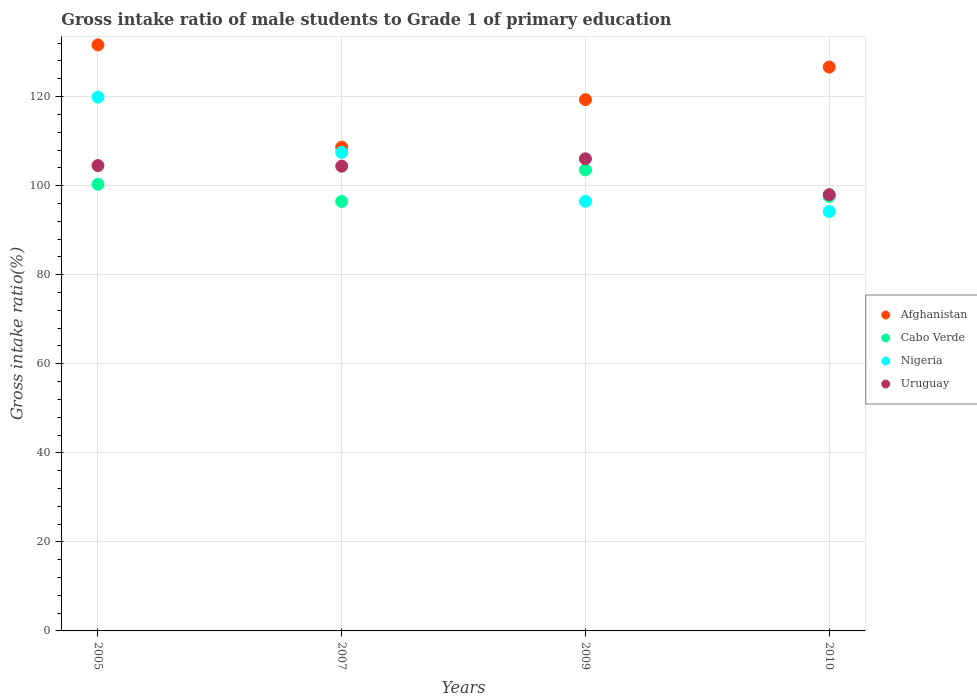What is the gross intake ratio in Nigeria in 2009?
Give a very brief answer. 96.48. Across all years, what is the maximum gross intake ratio in Uruguay?
Your response must be concise. 106.03. Across all years, what is the minimum gross intake ratio in Cabo Verde?
Provide a succinct answer. 96.45. In which year was the gross intake ratio in Cabo Verde maximum?
Provide a succinct answer. 2009. In which year was the gross intake ratio in Cabo Verde minimum?
Your answer should be compact. 2007. What is the total gross intake ratio in Uruguay in the graph?
Offer a very short reply. 412.89. What is the difference between the gross intake ratio in Cabo Verde in 2007 and that in 2009?
Your response must be concise. -7.09. What is the difference between the gross intake ratio in Afghanistan in 2005 and the gross intake ratio in Cabo Verde in 2009?
Provide a succinct answer. 28.07. What is the average gross intake ratio in Afghanistan per year?
Your answer should be compact. 121.55. In the year 2009, what is the difference between the gross intake ratio in Uruguay and gross intake ratio in Afghanistan?
Ensure brevity in your answer.  -13.29. What is the ratio of the gross intake ratio in Nigeria in 2007 to that in 2010?
Provide a succinct answer. 1.14. Is the gross intake ratio in Nigeria in 2005 less than that in 2010?
Your response must be concise. No. Is the difference between the gross intake ratio in Uruguay in 2005 and 2010 greater than the difference between the gross intake ratio in Afghanistan in 2005 and 2010?
Your answer should be compact. Yes. What is the difference between the highest and the second highest gross intake ratio in Cabo Verde?
Provide a succinct answer. 3.24. What is the difference between the highest and the lowest gross intake ratio in Nigeria?
Provide a succinct answer. 25.7. Is the sum of the gross intake ratio in Cabo Verde in 2005 and 2007 greater than the maximum gross intake ratio in Afghanistan across all years?
Provide a short and direct response. Yes. Is it the case that in every year, the sum of the gross intake ratio in Afghanistan and gross intake ratio in Uruguay  is greater than the sum of gross intake ratio in Nigeria and gross intake ratio in Cabo Verde?
Give a very brief answer. No. Is it the case that in every year, the sum of the gross intake ratio in Nigeria and gross intake ratio in Afghanistan  is greater than the gross intake ratio in Cabo Verde?
Offer a terse response. Yes. Does the gross intake ratio in Cabo Verde monotonically increase over the years?
Your answer should be very brief. No. Is the gross intake ratio in Cabo Verde strictly greater than the gross intake ratio in Nigeria over the years?
Ensure brevity in your answer.  No. How many dotlines are there?
Make the answer very short. 4. How many years are there in the graph?
Your answer should be very brief. 4. What is the difference between two consecutive major ticks on the Y-axis?
Your response must be concise. 20. Are the values on the major ticks of Y-axis written in scientific E-notation?
Give a very brief answer. No. Does the graph contain any zero values?
Provide a short and direct response. No. Does the graph contain grids?
Your response must be concise. Yes. Where does the legend appear in the graph?
Offer a very short reply. Center right. How are the legend labels stacked?
Your answer should be compact. Vertical. What is the title of the graph?
Offer a very short reply. Gross intake ratio of male students to Grade 1 of primary education. Does "Dominican Republic" appear as one of the legend labels in the graph?
Keep it short and to the point. No. What is the label or title of the X-axis?
Make the answer very short. Years. What is the label or title of the Y-axis?
Your response must be concise. Gross intake ratio(%). What is the Gross intake ratio(%) in Afghanistan in 2005?
Make the answer very short. 131.61. What is the Gross intake ratio(%) in Cabo Verde in 2005?
Give a very brief answer. 100.3. What is the Gross intake ratio(%) in Nigeria in 2005?
Your answer should be compact. 119.88. What is the Gross intake ratio(%) of Uruguay in 2005?
Offer a very short reply. 104.5. What is the Gross intake ratio(%) in Afghanistan in 2007?
Provide a short and direct response. 108.65. What is the Gross intake ratio(%) in Cabo Verde in 2007?
Offer a terse response. 96.45. What is the Gross intake ratio(%) in Nigeria in 2007?
Provide a short and direct response. 107.47. What is the Gross intake ratio(%) in Uruguay in 2007?
Give a very brief answer. 104.38. What is the Gross intake ratio(%) of Afghanistan in 2009?
Ensure brevity in your answer.  119.31. What is the Gross intake ratio(%) in Cabo Verde in 2009?
Ensure brevity in your answer.  103.54. What is the Gross intake ratio(%) of Nigeria in 2009?
Provide a succinct answer. 96.48. What is the Gross intake ratio(%) of Uruguay in 2009?
Your response must be concise. 106.03. What is the Gross intake ratio(%) in Afghanistan in 2010?
Ensure brevity in your answer.  126.63. What is the Gross intake ratio(%) in Cabo Verde in 2010?
Your answer should be compact. 97.59. What is the Gross intake ratio(%) of Nigeria in 2010?
Your answer should be compact. 94.18. What is the Gross intake ratio(%) in Uruguay in 2010?
Provide a succinct answer. 97.98. Across all years, what is the maximum Gross intake ratio(%) in Afghanistan?
Make the answer very short. 131.61. Across all years, what is the maximum Gross intake ratio(%) in Cabo Verde?
Give a very brief answer. 103.54. Across all years, what is the maximum Gross intake ratio(%) in Nigeria?
Ensure brevity in your answer.  119.88. Across all years, what is the maximum Gross intake ratio(%) of Uruguay?
Offer a terse response. 106.03. Across all years, what is the minimum Gross intake ratio(%) in Afghanistan?
Provide a succinct answer. 108.65. Across all years, what is the minimum Gross intake ratio(%) of Cabo Verde?
Provide a short and direct response. 96.45. Across all years, what is the minimum Gross intake ratio(%) in Nigeria?
Provide a succinct answer. 94.18. Across all years, what is the minimum Gross intake ratio(%) of Uruguay?
Give a very brief answer. 97.98. What is the total Gross intake ratio(%) in Afghanistan in the graph?
Make the answer very short. 486.2. What is the total Gross intake ratio(%) of Cabo Verde in the graph?
Provide a succinct answer. 397.87. What is the total Gross intake ratio(%) of Nigeria in the graph?
Provide a short and direct response. 418.01. What is the total Gross intake ratio(%) in Uruguay in the graph?
Offer a terse response. 412.89. What is the difference between the Gross intake ratio(%) of Afghanistan in 2005 and that in 2007?
Ensure brevity in your answer.  22.96. What is the difference between the Gross intake ratio(%) in Cabo Verde in 2005 and that in 2007?
Offer a very short reply. 3.85. What is the difference between the Gross intake ratio(%) in Nigeria in 2005 and that in 2007?
Your answer should be compact. 12.42. What is the difference between the Gross intake ratio(%) of Uruguay in 2005 and that in 2007?
Your answer should be compact. 0.13. What is the difference between the Gross intake ratio(%) in Afghanistan in 2005 and that in 2009?
Make the answer very short. 12.29. What is the difference between the Gross intake ratio(%) of Cabo Verde in 2005 and that in 2009?
Ensure brevity in your answer.  -3.24. What is the difference between the Gross intake ratio(%) in Nigeria in 2005 and that in 2009?
Your answer should be compact. 23.41. What is the difference between the Gross intake ratio(%) of Uruguay in 2005 and that in 2009?
Offer a terse response. -1.52. What is the difference between the Gross intake ratio(%) in Afghanistan in 2005 and that in 2010?
Offer a very short reply. 4.98. What is the difference between the Gross intake ratio(%) in Cabo Verde in 2005 and that in 2010?
Your answer should be compact. 2.71. What is the difference between the Gross intake ratio(%) in Nigeria in 2005 and that in 2010?
Offer a terse response. 25.7. What is the difference between the Gross intake ratio(%) in Uruguay in 2005 and that in 2010?
Make the answer very short. 6.52. What is the difference between the Gross intake ratio(%) of Afghanistan in 2007 and that in 2009?
Keep it short and to the point. -10.67. What is the difference between the Gross intake ratio(%) in Cabo Verde in 2007 and that in 2009?
Provide a succinct answer. -7.09. What is the difference between the Gross intake ratio(%) of Nigeria in 2007 and that in 2009?
Give a very brief answer. 10.99. What is the difference between the Gross intake ratio(%) of Uruguay in 2007 and that in 2009?
Make the answer very short. -1.65. What is the difference between the Gross intake ratio(%) of Afghanistan in 2007 and that in 2010?
Give a very brief answer. -17.98. What is the difference between the Gross intake ratio(%) of Cabo Verde in 2007 and that in 2010?
Make the answer very short. -1.14. What is the difference between the Gross intake ratio(%) in Nigeria in 2007 and that in 2010?
Ensure brevity in your answer.  13.29. What is the difference between the Gross intake ratio(%) in Uruguay in 2007 and that in 2010?
Offer a terse response. 6.39. What is the difference between the Gross intake ratio(%) of Afghanistan in 2009 and that in 2010?
Your answer should be very brief. -7.32. What is the difference between the Gross intake ratio(%) in Cabo Verde in 2009 and that in 2010?
Ensure brevity in your answer.  5.95. What is the difference between the Gross intake ratio(%) in Nigeria in 2009 and that in 2010?
Make the answer very short. 2.3. What is the difference between the Gross intake ratio(%) in Uruguay in 2009 and that in 2010?
Provide a short and direct response. 8.04. What is the difference between the Gross intake ratio(%) of Afghanistan in 2005 and the Gross intake ratio(%) of Cabo Verde in 2007?
Keep it short and to the point. 35.16. What is the difference between the Gross intake ratio(%) of Afghanistan in 2005 and the Gross intake ratio(%) of Nigeria in 2007?
Keep it short and to the point. 24.14. What is the difference between the Gross intake ratio(%) of Afghanistan in 2005 and the Gross intake ratio(%) of Uruguay in 2007?
Keep it short and to the point. 27.23. What is the difference between the Gross intake ratio(%) in Cabo Verde in 2005 and the Gross intake ratio(%) in Nigeria in 2007?
Ensure brevity in your answer.  -7.17. What is the difference between the Gross intake ratio(%) in Cabo Verde in 2005 and the Gross intake ratio(%) in Uruguay in 2007?
Offer a terse response. -4.08. What is the difference between the Gross intake ratio(%) in Nigeria in 2005 and the Gross intake ratio(%) in Uruguay in 2007?
Provide a succinct answer. 15.51. What is the difference between the Gross intake ratio(%) in Afghanistan in 2005 and the Gross intake ratio(%) in Cabo Verde in 2009?
Offer a terse response. 28.07. What is the difference between the Gross intake ratio(%) of Afghanistan in 2005 and the Gross intake ratio(%) of Nigeria in 2009?
Ensure brevity in your answer.  35.13. What is the difference between the Gross intake ratio(%) in Afghanistan in 2005 and the Gross intake ratio(%) in Uruguay in 2009?
Your answer should be compact. 25.58. What is the difference between the Gross intake ratio(%) in Cabo Verde in 2005 and the Gross intake ratio(%) in Nigeria in 2009?
Ensure brevity in your answer.  3.82. What is the difference between the Gross intake ratio(%) of Cabo Verde in 2005 and the Gross intake ratio(%) of Uruguay in 2009?
Your answer should be compact. -5.73. What is the difference between the Gross intake ratio(%) of Nigeria in 2005 and the Gross intake ratio(%) of Uruguay in 2009?
Keep it short and to the point. 13.86. What is the difference between the Gross intake ratio(%) in Afghanistan in 2005 and the Gross intake ratio(%) in Cabo Verde in 2010?
Offer a very short reply. 34.02. What is the difference between the Gross intake ratio(%) in Afghanistan in 2005 and the Gross intake ratio(%) in Nigeria in 2010?
Provide a succinct answer. 37.43. What is the difference between the Gross intake ratio(%) of Afghanistan in 2005 and the Gross intake ratio(%) of Uruguay in 2010?
Provide a short and direct response. 33.62. What is the difference between the Gross intake ratio(%) of Cabo Verde in 2005 and the Gross intake ratio(%) of Nigeria in 2010?
Give a very brief answer. 6.12. What is the difference between the Gross intake ratio(%) of Cabo Verde in 2005 and the Gross intake ratio(%) of Uruguay in 2010?
Your response must be concise. 2.32. What is the difference between the Gross intake ratio(%) in Nigeria in 2005 and the Gross intake ratio(%) in Uruguay in 2010?
Give a very brief answer. 21.9. What is the difference between the Gross intake ratio(%) in Afghanistan in 2007 and the Gross intake ratio(%) in Cabo Verde in 2009?
Offer a very short reply. 5.11. What is the difference between the Gross intake ratio(%) in Afghanistan in 2007 and the Gross intake ratio(%) in Nigeria in 2009?
Your answer should be compact. 12.17. What is the difference between the Gross intake ratio(%) of Afghanistan in 2007 and the Gross intake ratio(%) of Uruguay in 2009?
Offer a terse response. 2.62. What is the difference between the Gross intake ratio(%) of Cabo Verde in 2007 and the Gross intake ratio(%) of Nigeria in 2009?
Give a very brief answer. -0.03. What is the difference between the Gross intake ratio(%) of Cabo Verde in 2007 and the Gross intake ratio(%) of Uruguay in 2009?
Make the answer very short. -9.58. What is the difference between the Gross intake ratio(%) of Nigeria in 2007 and the Gross intake ratio(%) of Uruguay in 2009?
Your response must be concise. 1.44. What is the difference between the Gross intake ratio(%) in Afghanistan in 2007 and the Gross intake ratio(%) in Cabo Verde in 2010?
Provide a succinct answer. 11.06. What is the difference between the Gross intake ratio(%) in Afghanistan in 2007 and the Gross intake ratio(%) in Nigeria in 2010?
Ensure brevity in your answer.  14.47. What is the difference between the Gross intake ratio(%) in Afghanistan in 2007 and the Gross intake ratio(%) in Uruguay in 2010?
Offer a very short reply. 10.66. What is the difference between the Gross intake ratio(%) in Cabo Verde in 2007 and the Gross intake ratio(%) in Nigeria in 2010?
Provide a short and direct response. 2.27. What is the difference between the Gross intake ratio(%) in Cabo Verde in 2007 and the Gross intake ratio(%) in Uruguay in 2010?
Offer a very short reply. -1.54. What is the difference between the Gross intake ratio(%) in Nigeria in 2007 and the Gross intake ratio(%) in Uruguay in 2010?
Offer a very short reply. 9.48. What is the difference between the Gross intake ratio(%) of Afghanistan in 2009 and the Gross intake ratio(%) of Cabo Verde in 2010?
Give a very brief answer. 21.72. What is the difference between the Gross intake ratio(%) in Afghanistan in 2009 and the Gross intake ratio(%) in Nigeria in 2010?
Your response must be concise. 25.13. What is the difference between the Gross intake ratio(%) of Afghanistan in 2009 and the Gross intake ratio(%) of Uruguay in 2010?
Your answer should be compact. 21.33. What is the difference between the Gross intake ratio(%) in Cabo Verde in 2009 and the Gross intake ratio(%) in Nigeria in 2010?
Give a very brief answer. 9.36. What is the difference between the Gross intake ratio(%) in Cabo Verde in 2009 and the Gross intake ratio(%) in Uruguay in 2010?
Your answer should be compact. 5.55. What is the difference between the Gross intake ratio(%) in Nigeria in 2009 and the Gross intake ratio(%) in Uruguay in 2010?
Offer a terse response. -1.51. What is the average Gross intake ratio(%) of Afghanistan per year?
Offer a very short reply. 121.55. What is the average Gross intake ratio(%) in Cabo Verde per year?
Offer a terse response. 99.47. What is the average Gross intake ratio(%) of Nigeria per year?
Offer a terse response. 104.5. What is the average Gross intake ratio(%) in Uruguay per year?
Offer a very short reply. 103.22. In the year 2005, what is the difference between the Gross intake ratio(%) in Afghanistan and Gross intake ratio(%) in Cabo Verde?
Offer a terse response. 31.31. In the year 2005, what is the difference between the Gross intake ratio(%) in Afghanistan and Gross intake ratio(%) in Nigeria?
Offer a very short reply. 11.72. In the year 2005, what is the difference between the Gross intake ratio(%) in Afghanistan and Gross intake ratio(%) in Uruguay?
Ensure brevity in your answer.  27.1. In the year 2005, what is the difference between the Gross intake ratio(%) of Cabo Verde and Gross intake ratio(%) of Nigeria?
Offer a terse response. -19.58. In the year 2005, what is the difference between the Gross intake ratio(%) of Cabo Verde and Gross intake ratio(%) of Uruguay?
Your response must be concise. -4.21. In the year 2005, what is the difference between the Gross intake ratio(%) in Nigeria and Gross intake ratio(%) in Uruguay?
Your response must be concise. 15.38. In the year 2007, what is the difference between the Gross intake ratio(%) of Afghanistan and Gross intake ratio(%) of Cabo Verde?
Keep it short and to the point. 12.2. In the year 2007, what is the difference between the Gross intake ratio(%) of Afghanistan and Gross intake ratio(%) of Nigeria?
Your answer should be very brief. 1.18. In the year 2007, what is the difference between the Gross intake ratio(%) of Afghanistan and Gross intake ratio(%) of Uruguay?
Offer a terse response. 4.27. In the year 2007, what is the difference between the Gross intake ratio(%) of Cabo Verde and Gross intake ratio(%) of Nigeria?
Provide a short and direct response. -11.02. In the year 2007, what is the difference between the Gross intake ratio(%) of Cabo Verde and Gross intake ratio(%) of Uruguay?
Provide a succinct answer. -7.93. In the year 2007, what is the difference between the Gross intake ratio(%) in Nigeria and Gross intake ratio(%) in Uruguay?
Ensure brevity in your answer.  3.09. In the year 2009, what is the difference between the Gross intake ratio(%) of Afghanistan and Gross intake ratio(%) of Cabo Verde?
Give a very brief answer. 15.78. In the year 2009, what is the difference between the Gross intake ratio(%) in Afghanistan and Gross intake ratio(%) in Nigeria?
Provide a short and direct response. 22.83. In the year 2009, what is the difference between the Gross intake ratio(%) of Afghanistan and Gross intake ratio(%) of Uruguay?
Keep it short and to the point. 13.29. In the year 2009, what is the difference between the Gross intake ratio(%) in Cabo Verde and Gross intake ratio(%) in Nigeria?
Keep it short and to the point. 7.06. In the year 2009, what is the difference between the Gross intake ratio(%) in Cabo Verde and Gross intake ratio(%) in Uruguay?
Your answer should be compact. -2.49. In the year 2009, what is the difference between the Gross intake ratio(%) of Nigeria and Gross intake ratio(%) of Uruguay?
Ensure brevity in your answer.  -9.55. In the year 2010, what is the difference between the Gross intake ratio(%) of Afghanistan and Gross intake ratio(%) of Cabo Verde?
Keep it short and to the point. 29.04. In the year 2010, what is the difference between the Gross intake ratio(%) in Afghanistan and Gross intake ratio(%) in Nigeria?
Provide a succinct answer. 32.45. In the year 2010, what is the difference between the Gross intake ratio(%) of Afghanistan and Gross intake ratio(%) of Uruguay?
Make the answer very short. 28.65. In the year 2010, what is the difference between the Gross intake ratio(%) of Cabo Verde and Gross intake ratio(%) of Nigeria?
Provide a short and direct response. 3.41. In the year 2010, what is the difference between the Gross intake ratio(%) of Cabo Verde and Gross intake ratio(%) of Uruguay?
Keep it short and to the point. -0.4. In the year 2010, what is the difference between the Gross intake ratio(%) in Nigeria and Gross intake ratio(%) in Uruguay?
Make the answer very short. -3.8. What is the ratio of the Gross intake ratio(%) of Afghanistan in 2005 to that in 2007?
Keep it short and to the point. 1.21. What is the ratio of the Gross intake ratio(%) in Cabo Verde in 2005 to that in 2007?
Offer a terse response. 1.04. What is the ratio of the Gross intake ratio(%) in Nigeria in 2005 to that in 2007?
Provide a succinct answer. 1.12. What is the ratio of the Gross intake ratio(%) of Afghanistan in 2005 to that in 2009?
Give a very brief answer. 1.1. What is the ratio of the Gross intake ratio(%) in Cabo Verde in 2005 to that in 2009?
Offer a terse response. 0.97. What is the ratio of the Gross intake ratio(%) of Nigeria in 2005 to that in 2009?
Offer a very short reply. 1.24. What is the ratio of the Gross intake ratio(%) of Uruguay in 2005 to that in 2009?
Provide a short and direct response. 0.99. What is the ratio of the Gross intake ratio(%) in Afghanistan in 2005 to that in 2010?
Your response must be concise. 1.04. What is the ratio of the Gross intake ratio(%) of Cabo Verde in 2005 to that in 2010?
Your answer should be very brief. 1.03. What is the ratio of the Gross intake ratio(%) of Nigeria in 2005 to that in 2010?
Your response must be concise. 1.27. What is the ratio of the Gross intake ratio(%) in Uruguay in 2005 to that in 2010?
Keep it short and to the point. 1.07. What is the ratio of the Gross intake ratio(%) in Afghanistan in 2007 to that in 2009?
Make the answer very short. 0.91. What is the ratio of the Gross intake ratio(%) of Cabo Verde in 2007 to that in 2009?
Offer a terse response. 0.93. What is the ratio of the Gross intake ratio(%) in Nigeria in 2007 to that in 2009?
Your answer should be compact. 1.11. What is the ratio of the Gross intake ratio(%) in Uruguay in 2007 to that in 2009?
Make the answer very short. 0.98. What is the ratio of the Gross intake ratio(%) in Afghanistan in 2007 to that in 2010?
Offer a terse response. 0.86. What is the ratio of the Gross intake ratio(%) in Cabo Verde in 2007 to that in 2010?
Your answer should be compact. 0.99. What is the ratio of the Gross intake ratio(%) in Nigeria in 2007 to that in 2010?
Offer a terse response. 1.14. What is the ratio of the Gross intake ratio(%) of Uruguay in 2007 to that in 2010?
Make the answer very short. 1.07. What is the ratio of the Gross intake ratio(%) in Afghanistan in 2009 to that in 2010?
Your answer should be very brief. 0.94. What is the ratio of the Gross intake ratio(%) in Cabo Verde in 2009 to that in 2010?
Keep it short and to the point. 1.06. What is the ratio of the Gross intake ratio(%) of Nigeria in 2009 to that in 2010?
Provide a short and direct response. 1.02. What is the ratio of the Gross intake ratio(%) of Uruguay in 2009 to that in 2010?
Make the answer very short. 1.08. What is the difference between the highest and the second highest Gross intake ratio(%) of Afghanistan?
Offer a terse response. 4.98. What is the difference between the highest and the second highest Gross intake ratio(%) of Cabo Verde?
Keep it short and to the point. 3.24. What is the difference between the highest and the second highest Gross intake ratio(%) of Nigeria?
Your answer should be very brief. 12.42. What is the difference between the highest and the second highest Gross intake ratio(%) in Uruguay?
Offer a terse response. 1.52. What is the difference between the highest and the lowest Gross intake ratio(%) in Afghanistan?
Make the answer very short. 22.96. What is the difference between the highest and the lowest Gross intake ratio(%) in Cabo Verde?
Offer a terse response. 7.09. What is the difference between the highest and the lowest Gross intake ratio(%) of Nigeria?
Make the answer very short. 25.7. What is the difference between the highest and the lowest Gross intake ratio(%) of Uruguay?
Provide a short and direct response. 8.04. 